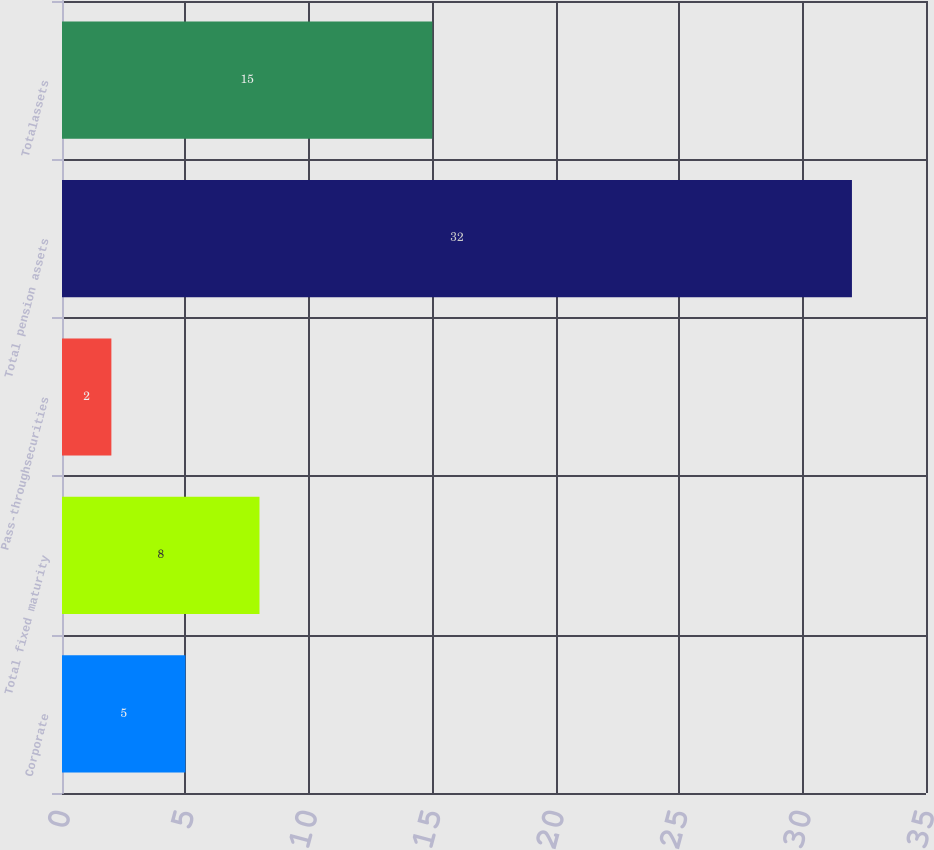<chart> <loc_0><loc_0><loc_500><loc_500><bar_chart><fcel>Corporate<fcel>Total fixed maturity<fcel>Pass-throughsecurities<fcel>Total pension assets<fcel>Totalassets<nl><fcel>5<fcel>8<fcel>2<fcel>32<fcel>15<nl></chart> 